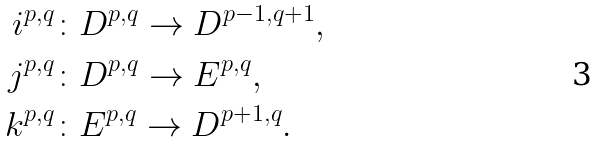<formula> <loc_0><loc_0><loc_500><loc_500>i ^ { p , q } & \colon D ^ { p , q } \to D ^ { p - 1 , q + 1 } , \\ j ^ { p , q } & \colon D ^ { p , q } \to E ^ { p , q } , \\ k ^ { p , q } & \colon E ^ { p , q } \to D ^ { p + 1 , q } .</formula> 